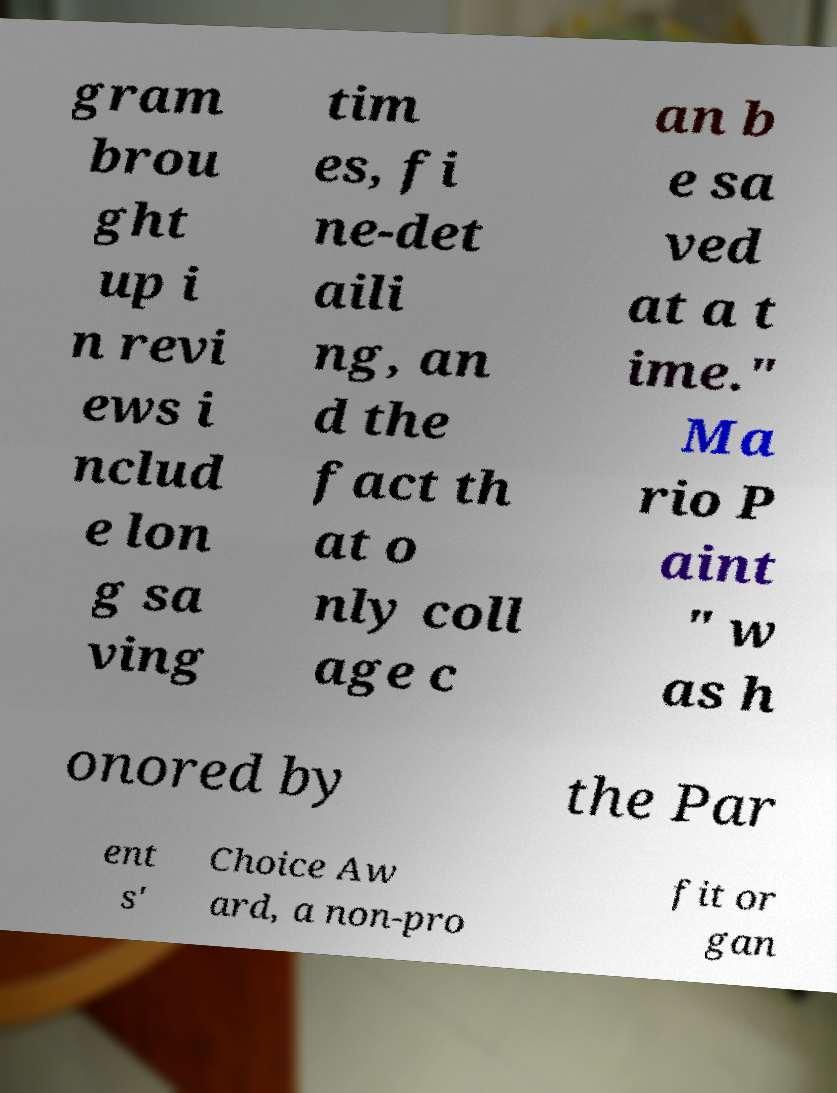Please read and relay the text visible in this image. What does it say? gram brou ght up i n revi ews i nclud e lon g sa ving tim es, fi ne-det aili ng, an d the fact th at o nly coll age c an b e sa ved at a t ime." Ma rio P aint " w as h onored by the Par ent s' Choice Aw ard, a non-pro fit or gan 